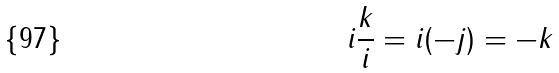Convert formula to latex. <formula><loc_0><loc_0><loc_500><loc_500>i \frac { k } { i } = i ( - j ) = - k</formula> 